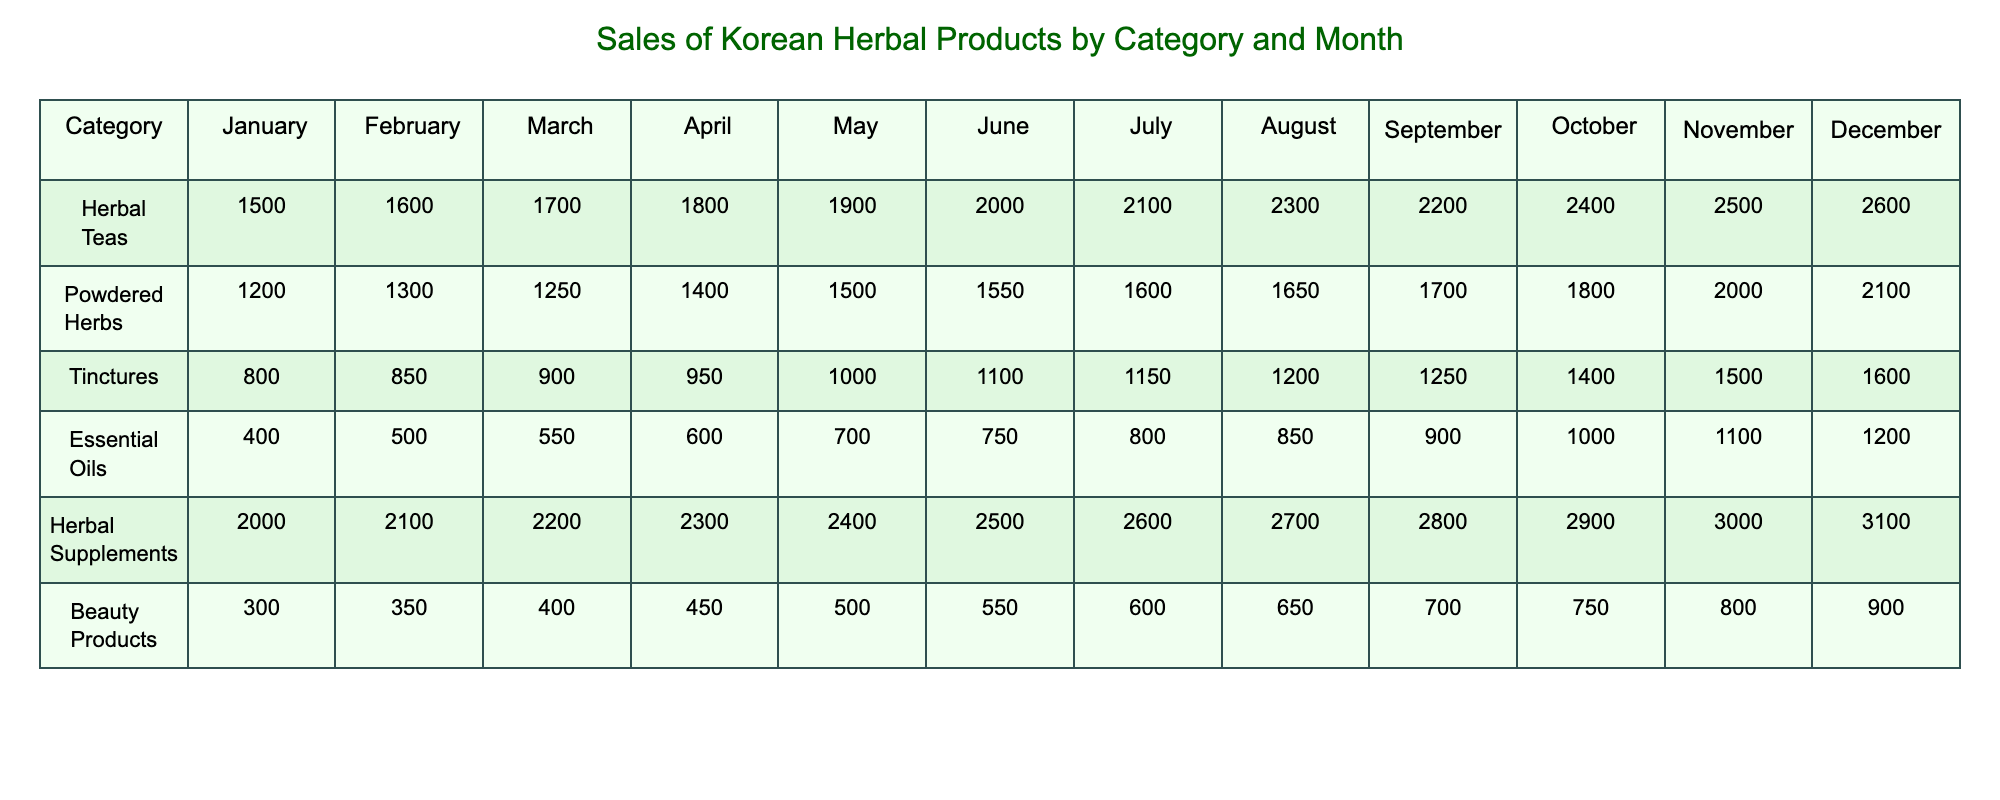What was the highest sales figure in December among all categories? The table shows the sales figures for December across all categories. The values for December are: Herbal Teas 2600, Powdered Herbs 2100, Tinctures 1600, Essential Oils 1200, Herbal Supplements 3100, and Beauty Products 900. The highest value is 3100 from Herbal Supplements.
Answer: 3100 Which category had the largest increase in sales from January to May? To find the largest increase from January to May, we look at the sales figures for each category in January (Herbal Teas 1500, Powdered Herbs 1200, Tinctures 800, Essential Oils 400, Herbal Supplements 2000, Beauty Products 300) and May (Herbal Teas 1900, Powdered Herbs 1500, Tinctures 1000, Essential Oils 700, Herbal Supplements 2400, Beauty Products 500). The increases are: Herbal Teas 400, Powdered Herbs 300, Tinctures 200, Essential Oils 300, Herbal Supplements 400, and Beauty Products 200. Herbal Teas and Herbal Supplements both had the largest increase of 400.
Answer: Herbal Teas and Herbal Supplements What was the total sales for Herbal Supplements in the second half of the year (July to December)? We sum the sales figures for Herbal Supplements from July to December: 2600 (July) + 2700 (August) + 2800 (September) + 2900 (October) + 3000 (November) + 3100 (December) = 17400.
Answer: 17400 Did Essential Oils see an increase in sales every month? Looking at the sales figures for Essential Oils across the months, we see: 400, 500, 550, 600, 700, 750, 800, 850, 900, 1000, 1100, 1200. All values are greater than the previous month's, indicating that sales increased every month.
Answer: Yes What was the average monthly sales for Powdered Herbs? To calculate the average monthly sales for Powdered Herbs, we first sum the sales figures from January to December: 1200 + 1300 + 1250 + 1400 + 1500 + 1550 + 1600 + 1650 + 1700 + 1800 + 2000 + 2100 = 18800. Then divide by the number of months, which is 12: 18800 / 12 = 1566.67.
Answer: 1566.67 